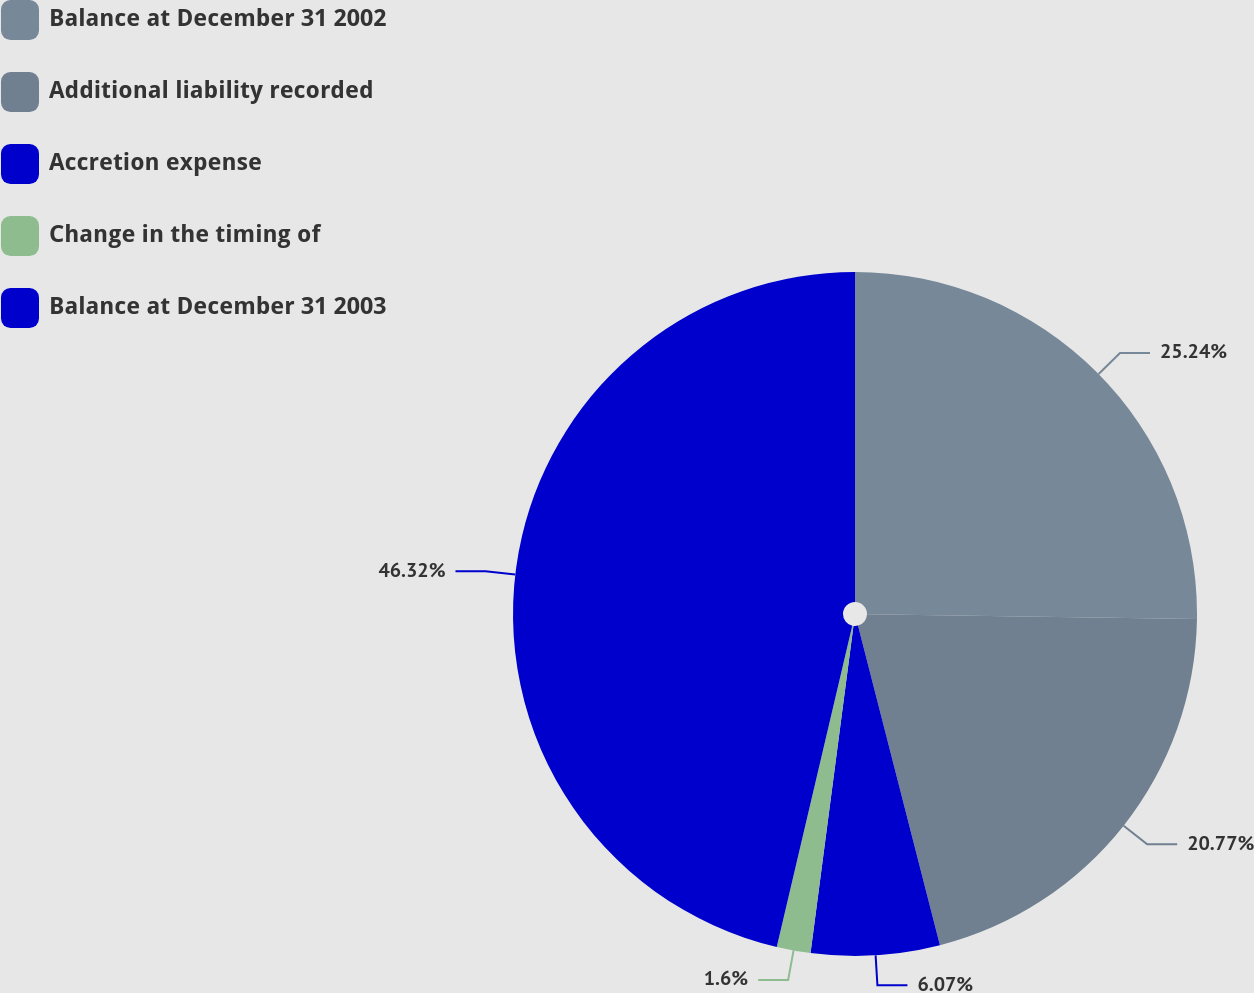Convert chart to OTSL. <chart><loc_0><loc_0><loc_500><loc_500><pie_chart><fcel>Balance at December 31 2002<fcel>Additional liability recorded<fcel>Accretion expense<fcel>Change in the timing of<fcel>Balance at December 31 2003<nl><fcel>25.24%<fcel>20.77%<fcel>6.07%<fcel>1.6%<fcel>46.33%<nl></chart> 